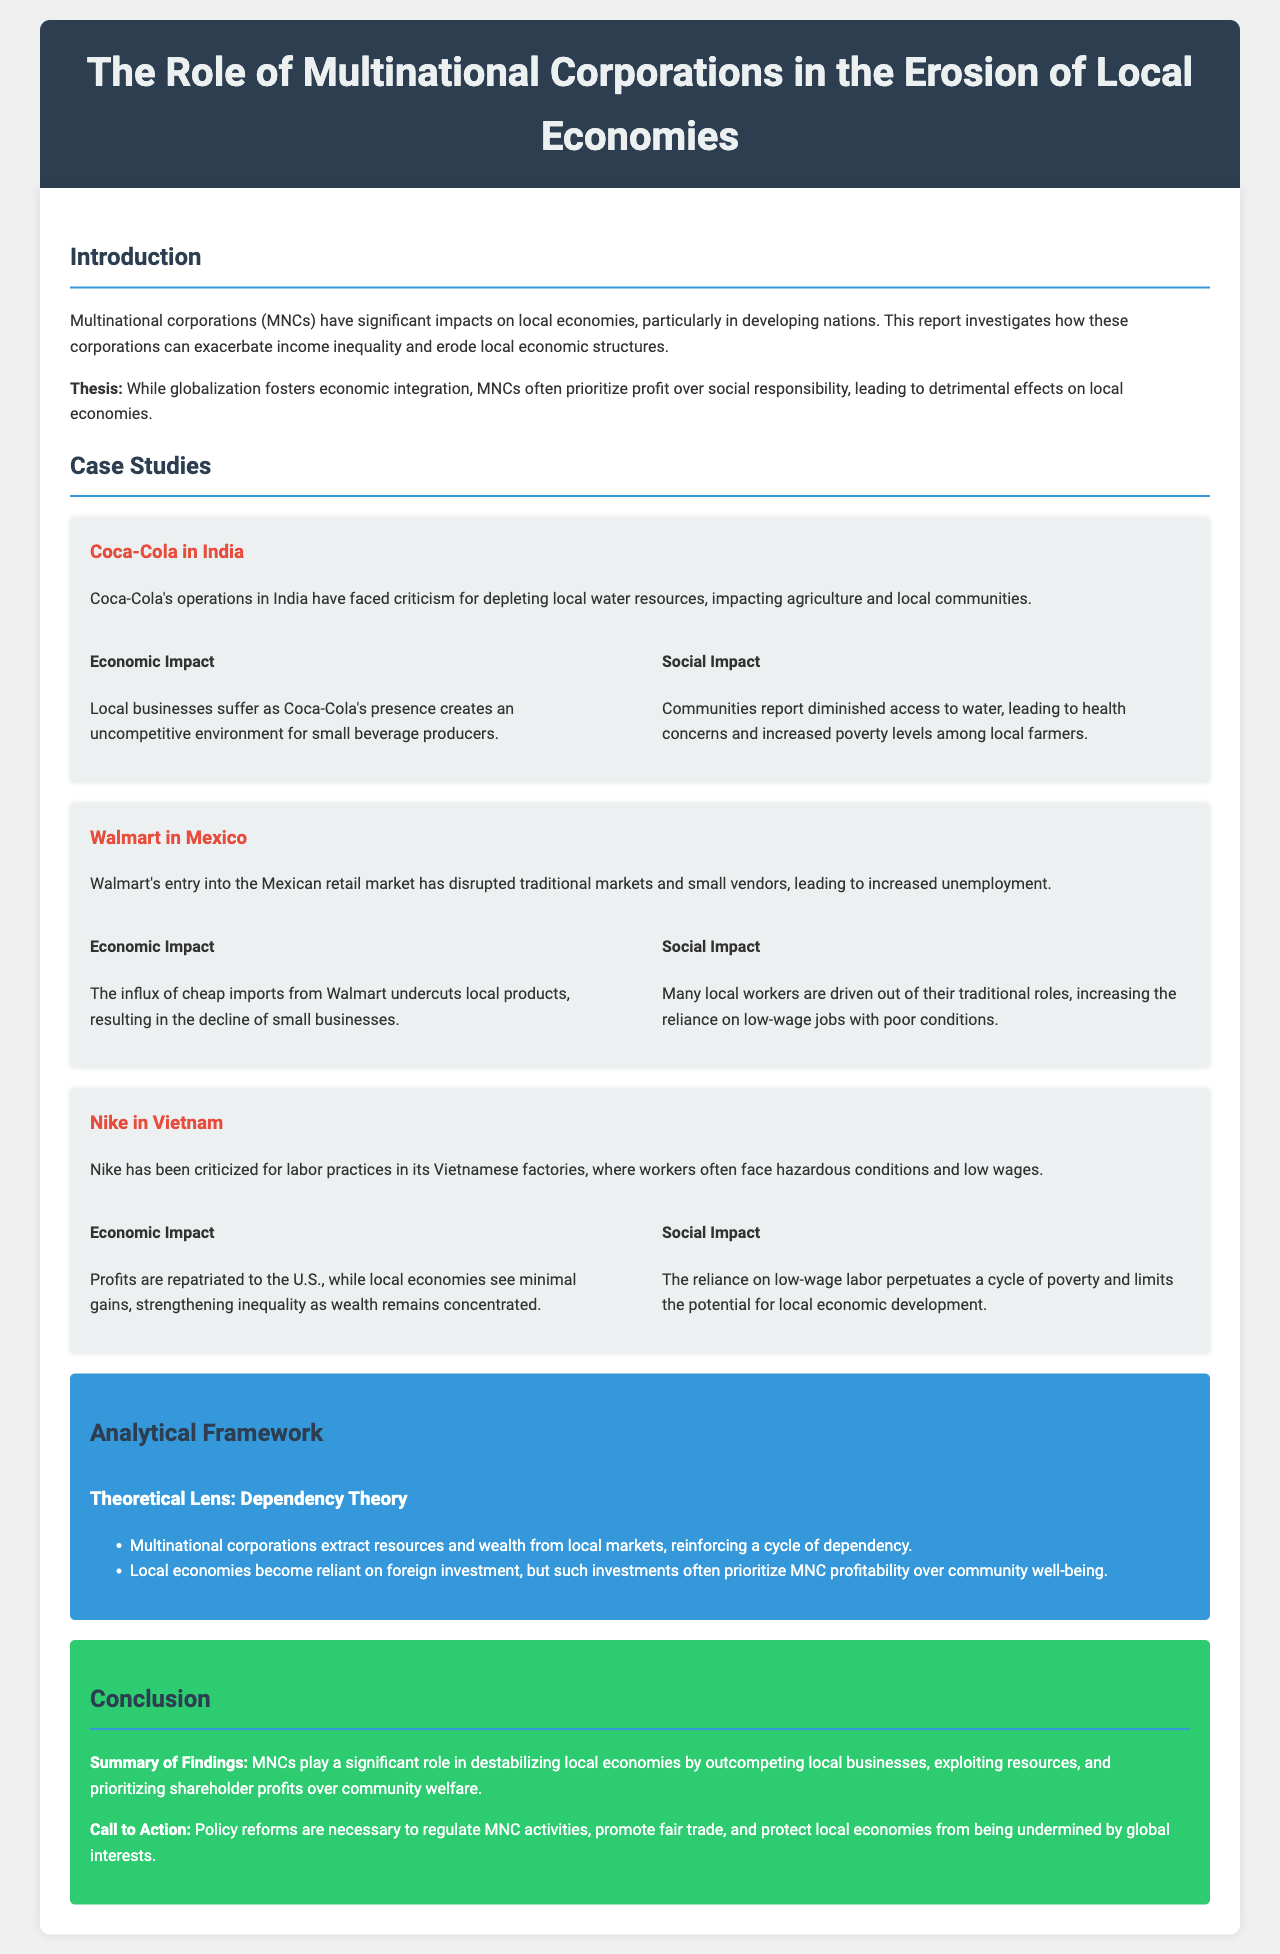what is the title of the report? The title is stated at the top of the document, introducing the subject of the report.
Answer: The Role of Multinational Corporations in the Erosion of Local Economies what is Coca-Cola criticized for in India? The report mentions specific criticisms regarding Coca-Cola's operations and their effect on local resources.
Answer: Depleting local water resources how does Walmart impact small vendors in Mexico? The case study section discusses Walmart's effects on traditional market structures and employment.
Answer: Disrupted traditional markets what theoretical lens is used in the analytical framework? The analytical framework section defines the perspective through which the impacts of MNCs are analyzed.
Answer: Dependency Theory what is the primary negative impact of Nike's practices in Vietnam? The discussion of Nike highlights serious issues regarding labor and economic implications.
Answer: Hazardous conditions and low wages what is the recommended call to action in the conclusion? The conclusion summarizes the findings and suggests a course of action to address the issues discussed.
Answer: Policy reforms are necessary how do MNCs generally approach local investments according to the document? The report implies the prioritization of profit over local community welfare regarding MNC activities.
Answer: Prioritize shareholder profits what year is the data current as of? The information at the start indicates the latest data and trends analyzed in the report.
Answer: October 2023 